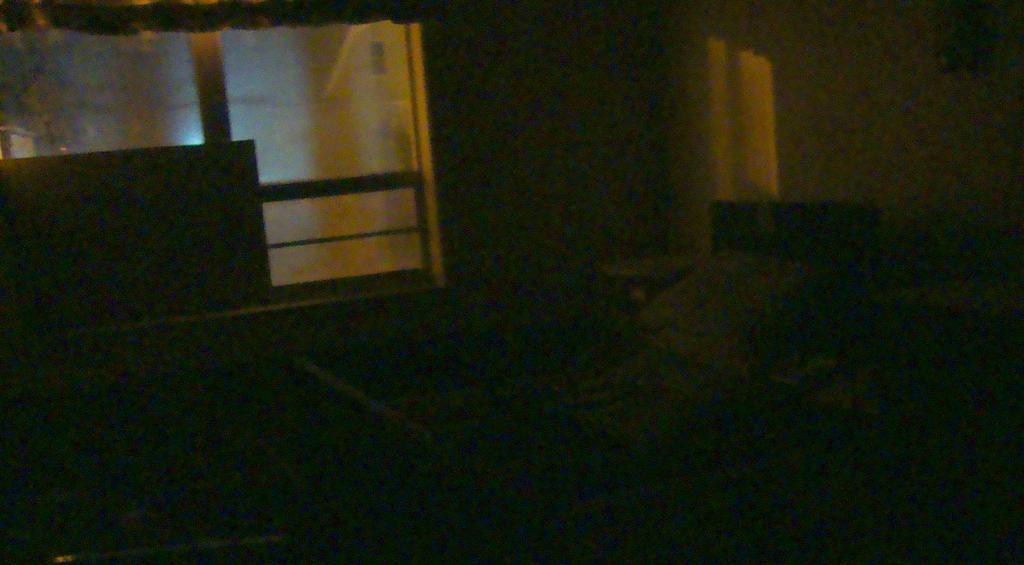Describe this image in one or two sentences. In front of the image it is dark. In the background, on the wall there are glass windows. Behind the windows there is a building. 